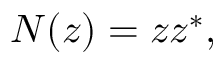Convert formula to latex. <formula><loc_0><loc_0><loc_500><loc_500>N ( z ) = z z ^ { * } ,</formula> 